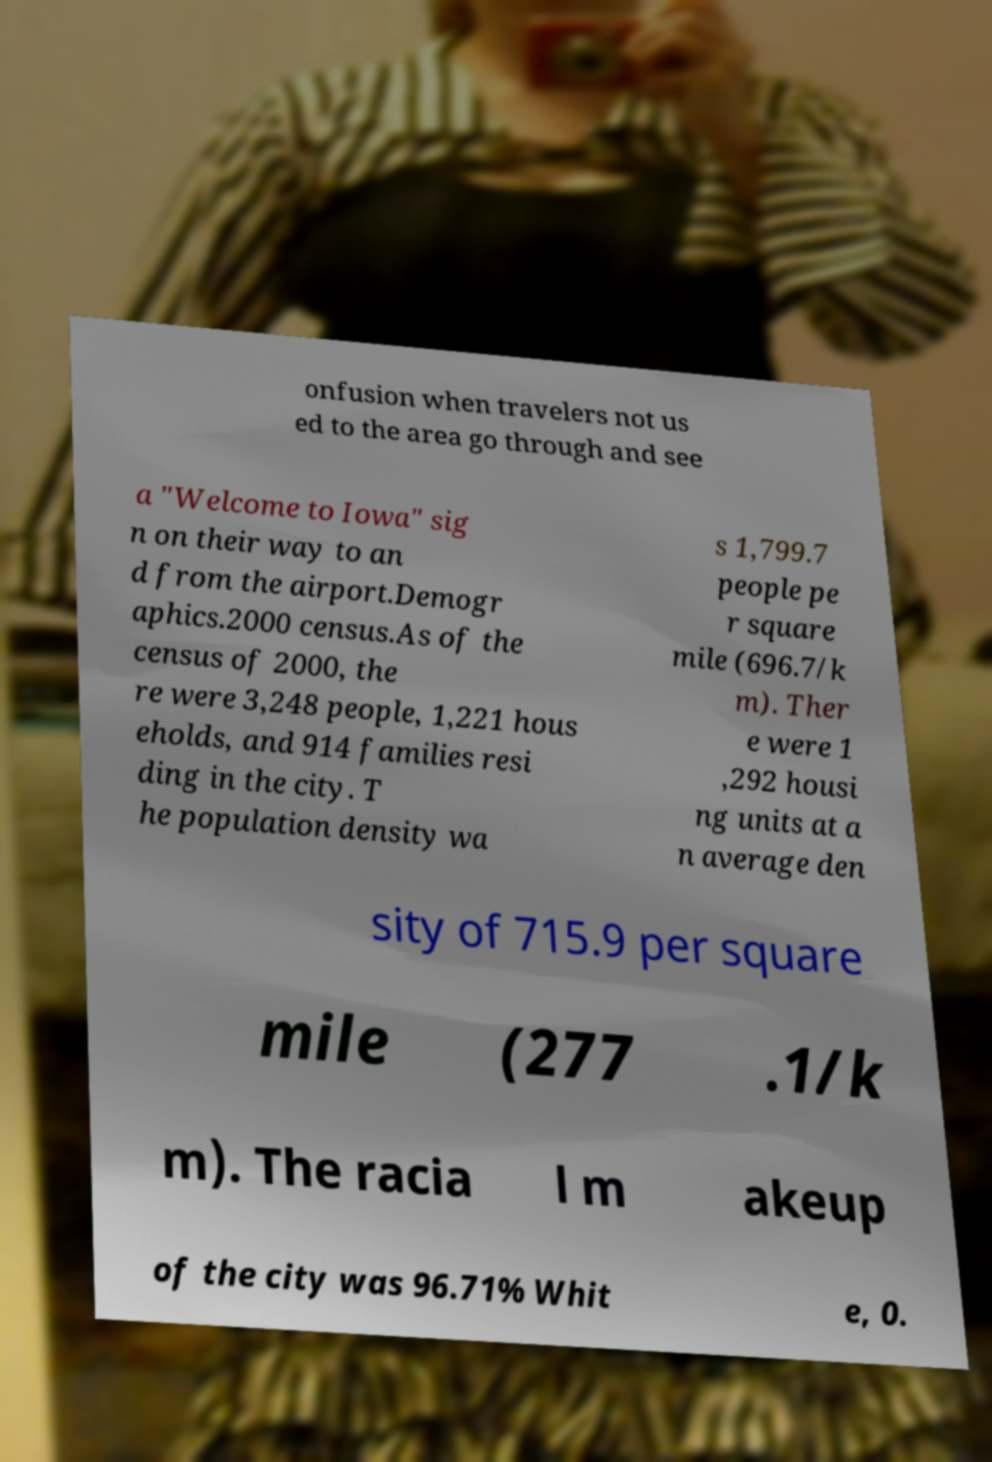I need the written content from this picture converted into text. Can you do that? onfusion when travelers not us ed to the area go through and see a "Welcome to Iowa" sig n on their way to an d from the airport.Demogr aphics.2000 census.As of the census of 2000, the re were 3,248 people, 1,221 hous eholds, and 914 families resi ding in the city. T he population density wa s 1,799.7 people pe r square mile (696.7/k m). Ther e were 1 ,292 housi ng units at a n average den sity of 715.9 per square mile (277 .1/k m). The racia l m akeup of the city was 96.71% Whit e, 0. 